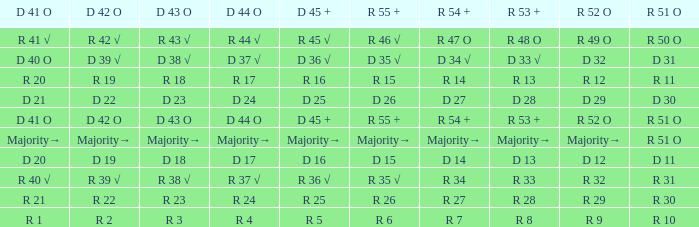What is the value of D 42 O that has an R 53 + value of r 8? R 2. 